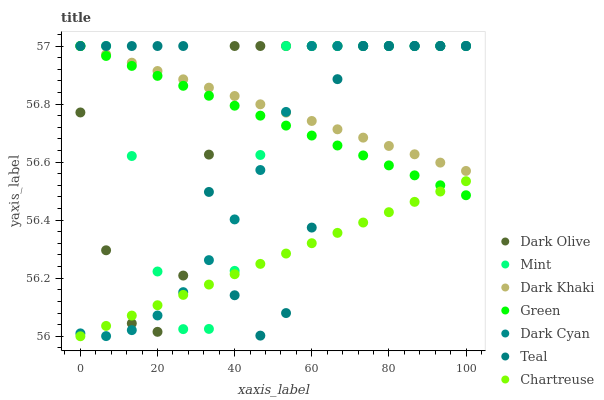Does Chartreuse have the minimum area under the curve?
Answer yes or no. Yes. Does Dark Khaki have the maximum area under the curve?
Answer yes or no. Yes. Does Dark Khaki have the minimum area under the curve?
Answer yes or no. No. Does Chartreuse have the maximum area under the curve?
Answer yes or no. No. Is Dark Khaki the smoothest?
Answer yes or no. Yes. Is Teal the roughest?
Answer yes or no. Yes. Is Chartreuse the smoothest?
Answer yes or no. No. Is Chartreuse the roughest?
Answer yes or no. No. Does Chartreuse have the lowest value?
Answer yes or no. Yes. Does Dark Khaki have the lowest value?
Answer yes or no. No. Does Mint have the highest value?
Answer yes or no. Yes. Does Chartreuse have the highest value?
Answer yes or no. No. Is Chartreuse less than Dark Khaki?
Answer yes or no. Yes. Is Dark Khaki greater than Chartreuse?
Answer yes or no. Yes. Does Mint intersect Dark Cyan?
Answer yes or no. Yes. Is Mint less than Dark Cyan?
Answer yes or no. No. Is Mint greater than Dark Cyan?
Answer yes or no. No. Does Chartreuse intersect Dark Khaki?
Answer yes or no. No. 